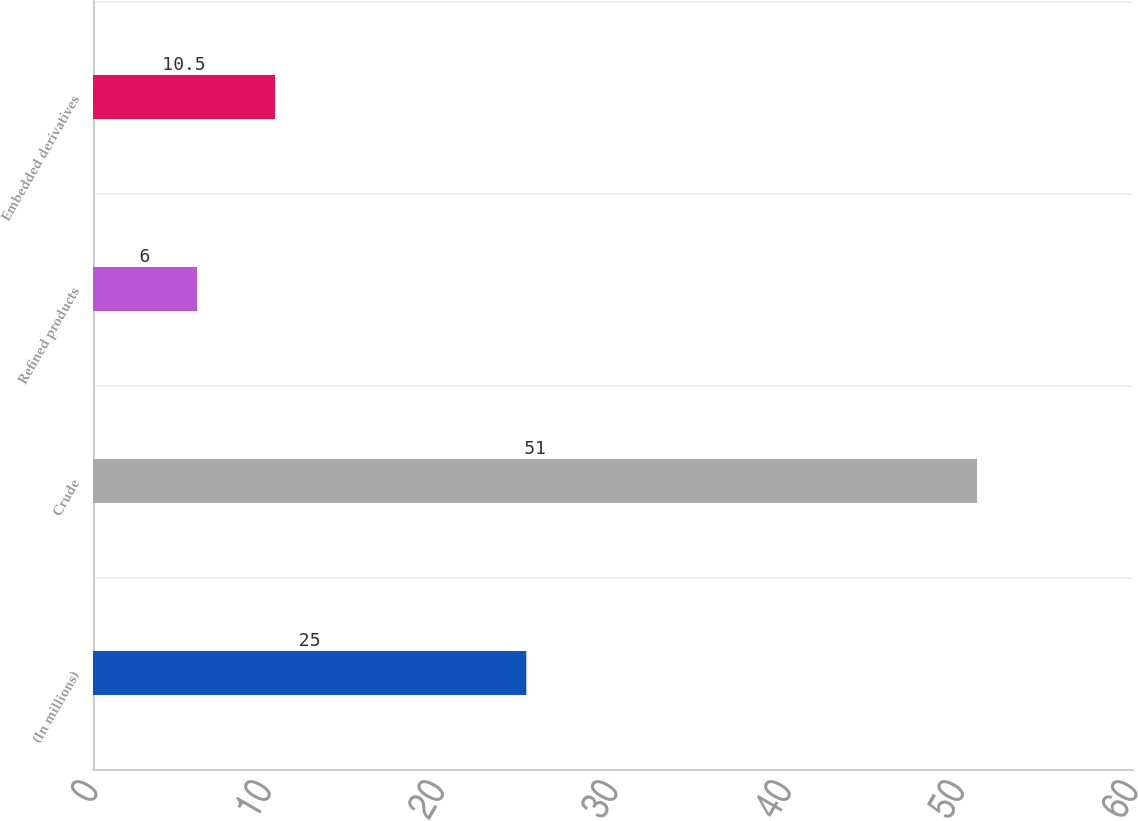<chart> <loc_0><loc_0><loc_500><loc_500><bar_chart><fcel>(In millions)<fcel>Crude<fcel>Refined products<fcel>Embedded derivatives<nl><fcel>25<fcel>51<fcel>6<fcel>10.5<nl></chart> 